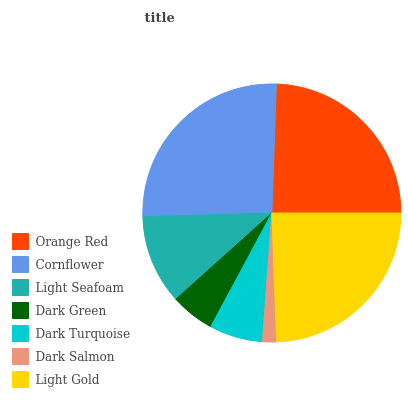Is Dark Salmon the minimum?
Answer yes or no. Yes. Is Cornflower the maximum?
Answer yes or no. Yes. Is Light Seafoam the minimum?
Answer yes or no. No. Is Light Seafoam the maximum?
Answer yes or no. No. Is Cornflower greater than Light Seafoam?
Answer yes or no. Yes. Is Light Seafoam less than Cornflower?
Answer yes or no. Yes. Is Light Seafoam greater than Cornflower?
Answer yes or no. No. Is Cornflower less than Light Seafoam?
Answer yes or no. No. Is Light Seafoam the high median?
Answer yes or no. Yes. Is Light Seafoam the low median?
Answer yes or no. Yes. Is Light Gold the high median?
Answer yes or no. No. Is Orange Red the low median?
Answer yes or no. No. 